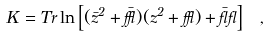<formula> <loc_0><loc_0><loc_500><loc_500>K = T r \ln \left [ ( \bar { z } ^ { 2 } + \bar { \epsilon } ) ( z ^ { 2 } + \epsilon ) + \bar { \gamma } \gamma \right ] \ ,</formula> 